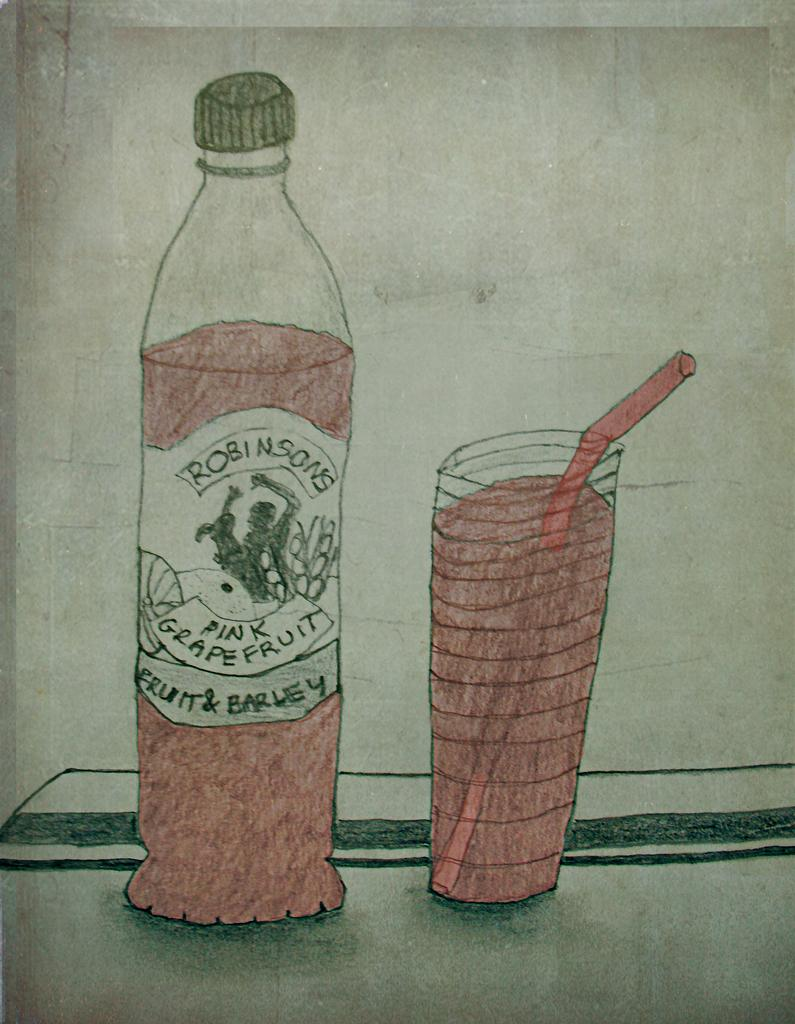What type of medium is used to create the art piece in the image? The art piece is created on paper with a pencil. What objects can be seen on the table in the image? There is a bottle and a glass of juice on the table in the image. What is the primary subject of the image? The image is an art piece. What type of business is being advertised in the image? There is no business or advertisement present in the image; it is an art piece created with a pencil on paper. What type of liquid is in the glass on the table? The image does not specify the type of liquid in the glass; it is simply described as a glass of juice. 